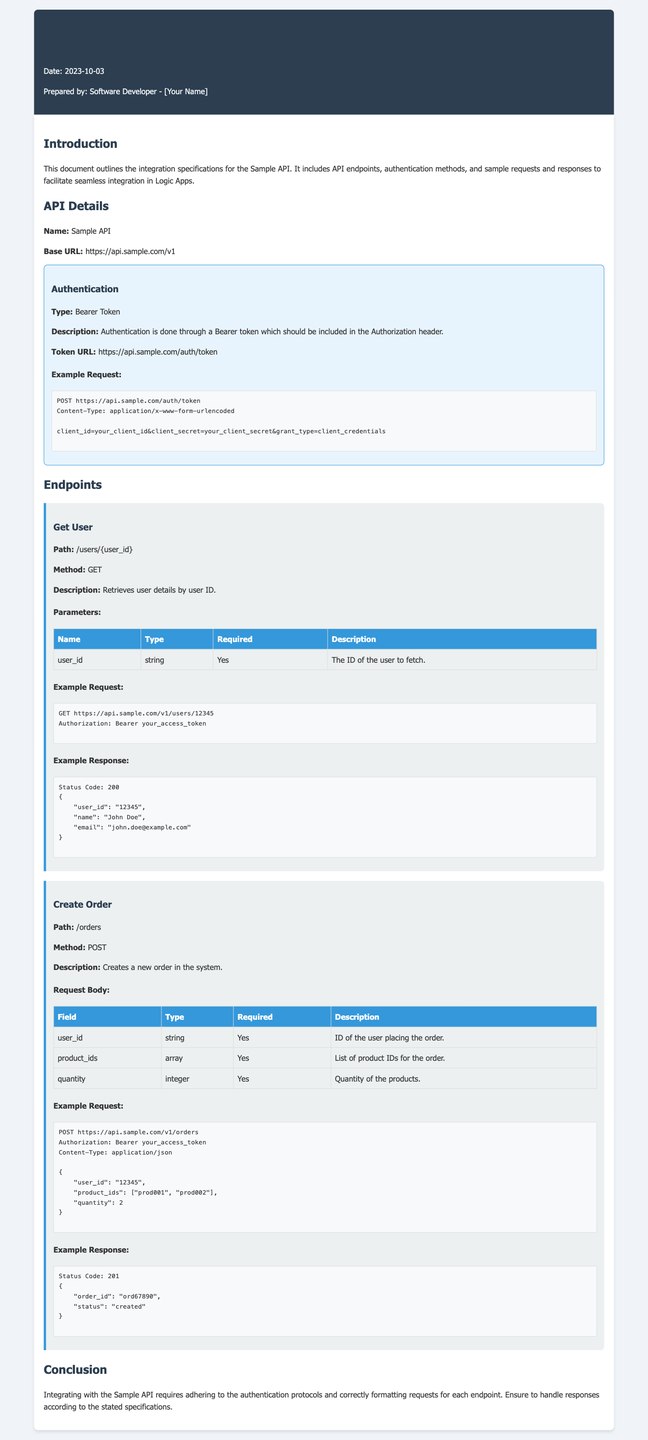What is the base URL of the Sample API? The base URL is mentioned in the API details section of the document.
Answer: https://api.sample.com/v1 What is the authentication type used by the Sample API? The authentication type is specified in the authentication section of the document.
Answer: Bearer Token What is the example request method for the "Create Order" endpoint? The request method for creating an order is found in the details of the endpoint in the document.
Answer: POST How many required parameters are there for the "Get User" endpoint? The number of required parameters is listed in the parameters table under the "Get User" endpoint.
Answer: 1 What is the status code for a successful order creation response? The status code for a successful response is provided in the example response of the "Create Order" endpoint.
Answer: 201 What is the path for retrieving user details? The path for this operation is found in the endpoint section under "Get User."
Answer: /users/{user_id} What should be included in the Authorization header? The required content in the Authorization header is mentioned in the authentication section of the document.
Answer: Bearer token What example user ID is given in the "Get User" example request? The example user ID can be found in the example request section for the "Get User" endpoint.
Answer: 12345 